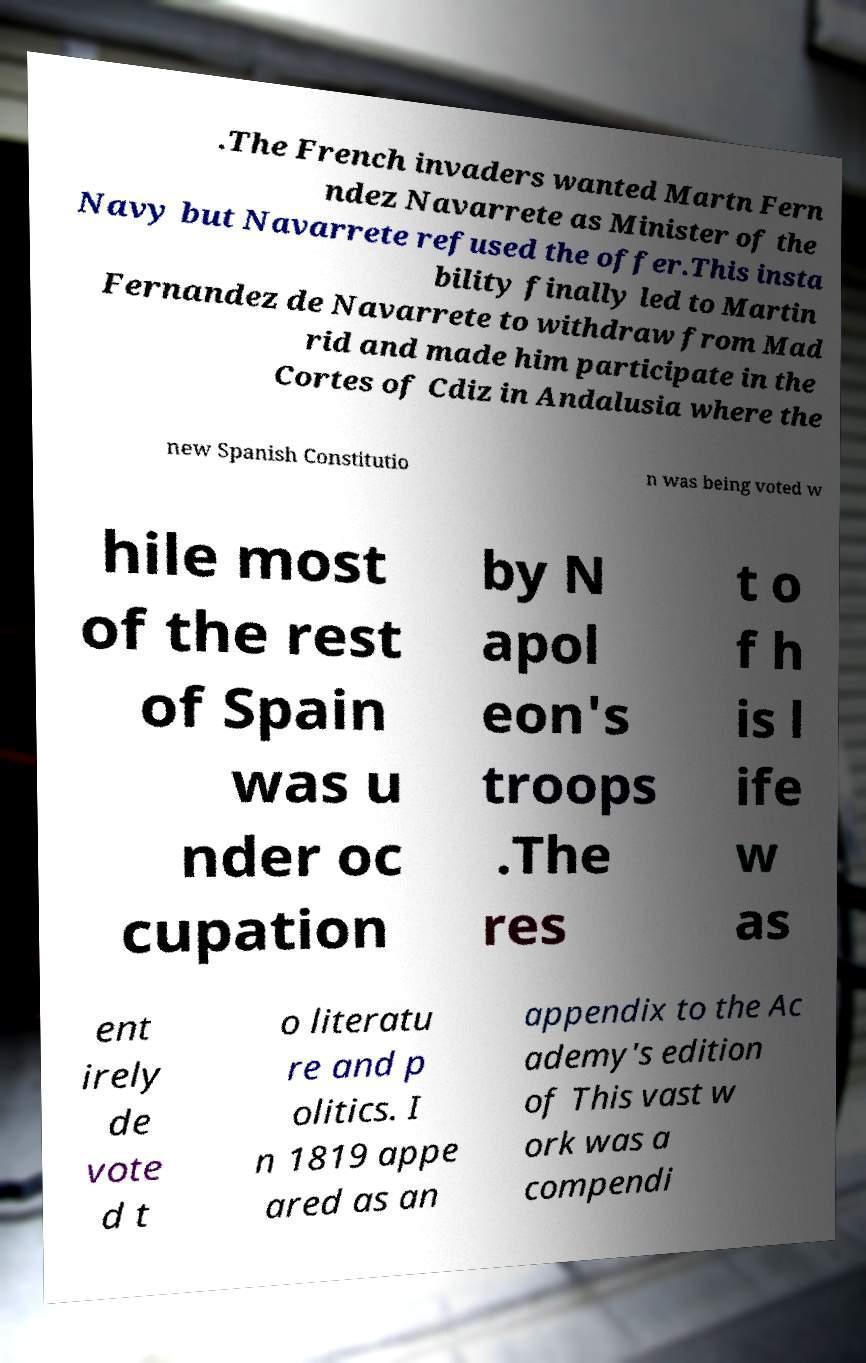Please read and relay the text visible in this image. What does it say? .The French invaders wanted Martn Fern ndez Navarrete as Minister of the Navy but Navarrete refused the offer.This insta bility finally led to Martin Fernandez de Navarrete to withdraw from Mad rid and made him participate in the Cortes of Cdiz in Andalusia where the new Spanish Constitutio n was being voted w hile most of the rest of Spain was u nder oc cupation by N apol eon's troops .The res t o f h is l ife w as ent irely de vote d t o literatu re and p olitics. I n 1819 appe ared as an appendix to the Ac ademy's edition of This vast w ork was a compendi 